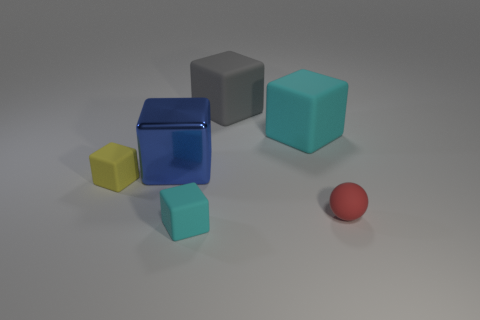Subtract all blue shiny cubes. How many cubes are left? 4 Subtract all blue cylinders. How many cyan blocks are left? 2 Add 3 gray matte blocks. How many objects exist? 9 Subtract all cubes. How many objects are left? 1 Subtract 3 cubes. How many cubes are left? 2 Add 2 gray cubes. How many gray cubes are left? 3 Add 1 small purple metallic cylinders. How many small purple metallic cylinders exist? 1 Subtract all gray blocks. How many blocks are left? 4 Subtract 0 purple cylinders. How many objects are left? 6 Subtract all blue blocks. Subtract all red cylinders. How many blocks are left? 4 